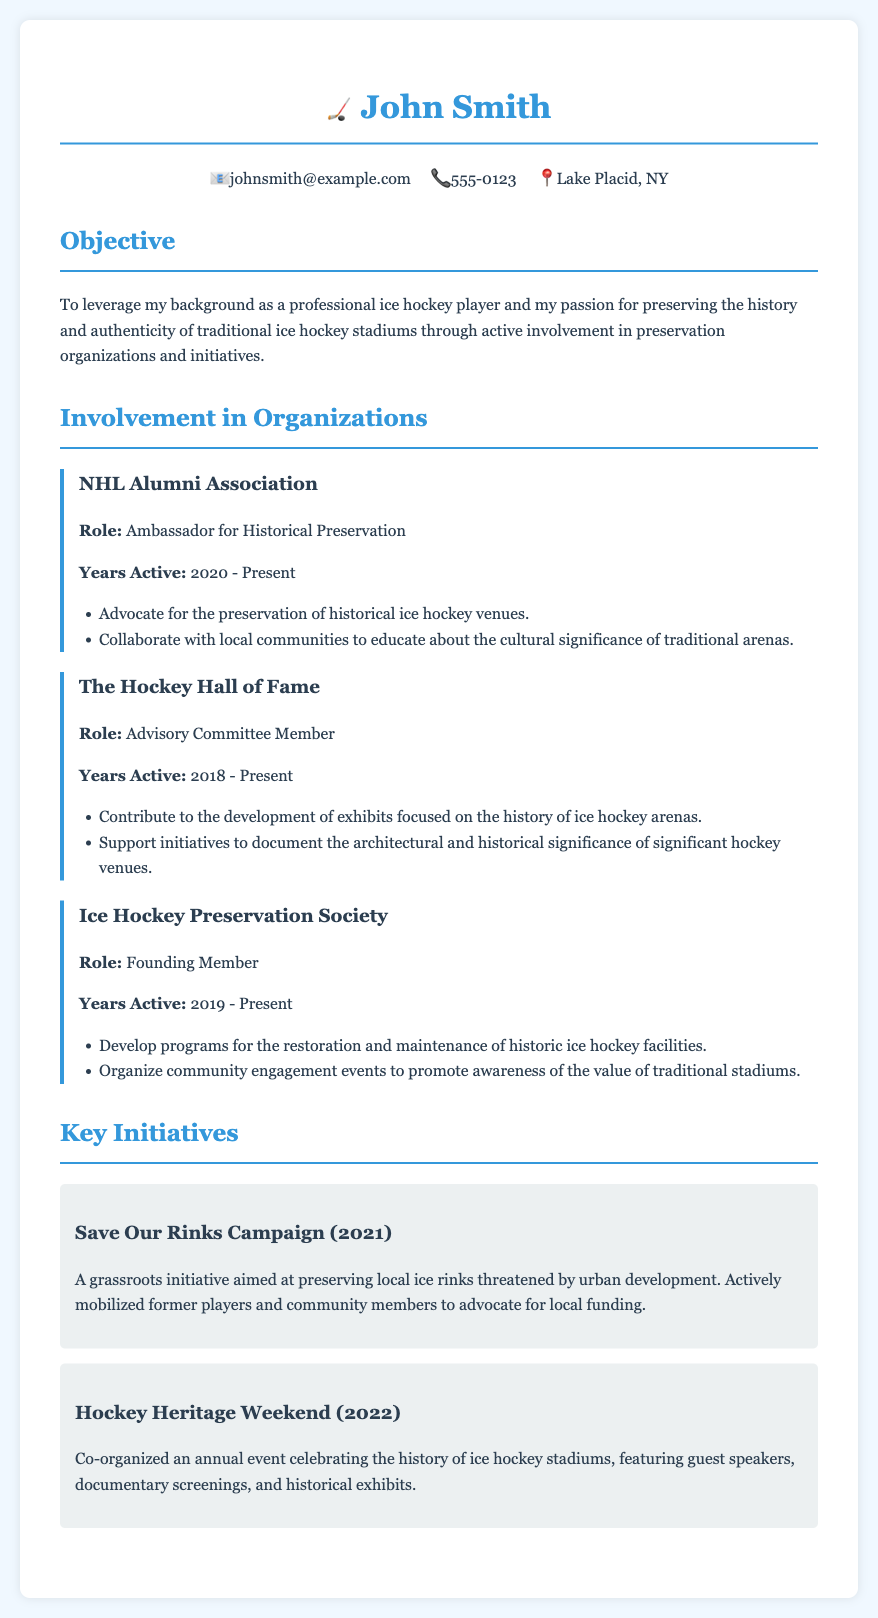What is John Smith's role in the NHL Alumni Association? The document states that John Smith is an Ambassador for Historical Preservation in the NHL Alumni Association.
Answer: Ambassador for Historical Preservation How many years has John Smith been active in the Ice Hockey Preservation Society? The document indicates that John Smith has been active in the Ice Hockey Preservation Society since 2019 and is currently active, which totals to 4 years.
Answer: 4 years What year did the Save Our Rinks Campaign take place? The document specifies that the Save Our Rinks Campaign occurred in 2021.
Answer: 2021 Which organization focuses on the history of ice hockey arenas? The document notes that The Hockey Hall of Fame focuses on developing exhibits relating to the history of ice hockey arenas.
Answer: The Hockey Hall of Fame What initiative was co-organized by John Smith in 2022? According to the document, John Smith co-organized the Hockey Heritage Weekend in 2022.
Answer: Hockey Heritage Weekend What is the objective of the Ice Hockey Preservation Society? The document outlines that the Ice Hockey Preservation Society aims to develop programs for the restoration and maintenance of historic ice hockey facilities.
Answer: Restoration and maintenance of historic ice hockey facilities How many organizations is John Smith involved with? The document lists three organizations that John Smith is involved with: NHL Alumni Association, The Hockey Hall of Fame, and Ice Hockey Preservation Society.
Answer: Three organizations What type of events did the Hockey Heritage Weekend feature? The document describes that the Hockey Heritage Weekend featured guest speakers, documentary screenings, and historical exhibits.
Answer: Guest speakers, documentary screenings, and historical exhibits What is John Smith's location? The document provides that John Smith is located in Lake Placid, NY.
Answer: Lake Placid, NY 